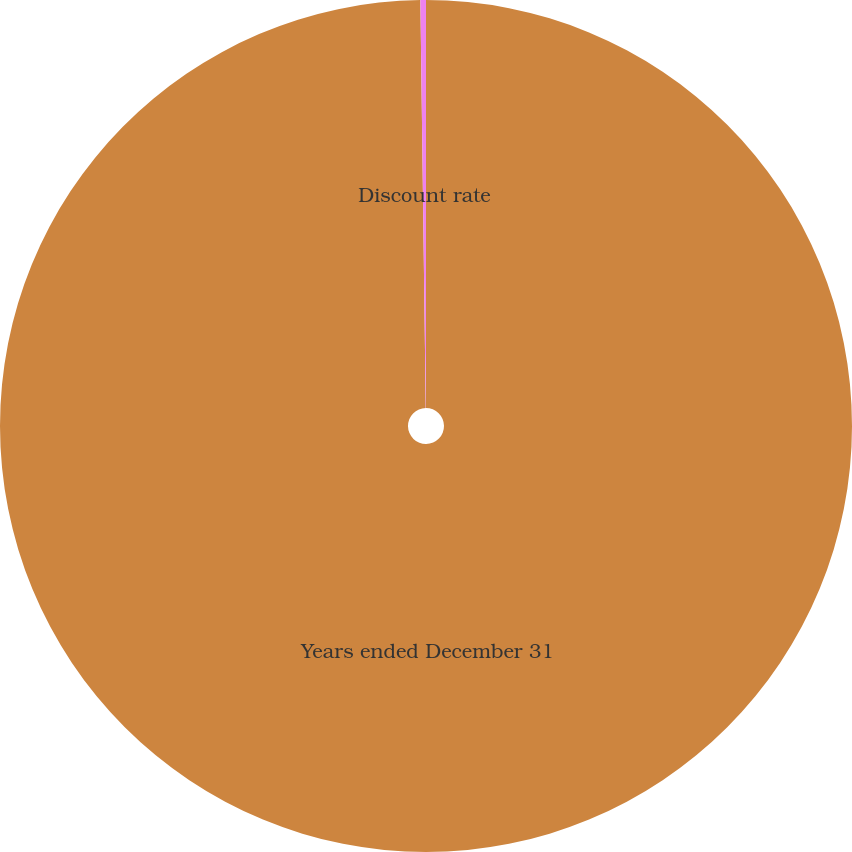<chart> <loc_0><loc_0><loc_500><loc_500><pie_chart><fcel>Years ended December 31<fcel>Discount rate<nl><fcel>99.79%<fcel>0.21%<nl></chart> 